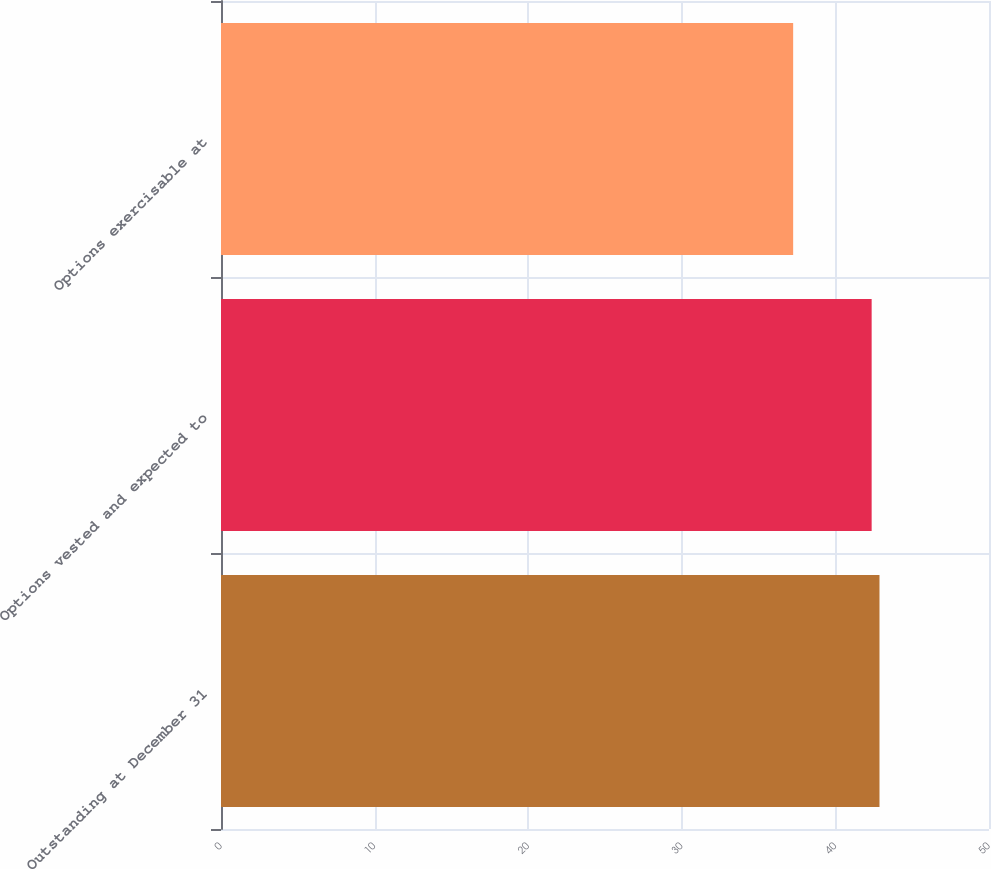<chart> <loc_0><loc_0><loc_500><loc_500><bar_chart><fcel>Outstanding at December 31<fcel>Options vested and expected to<fcel>Options exercisable at<nl><fcel>42.87<fcel>42.36<fcel>37.25<nl></chart> 